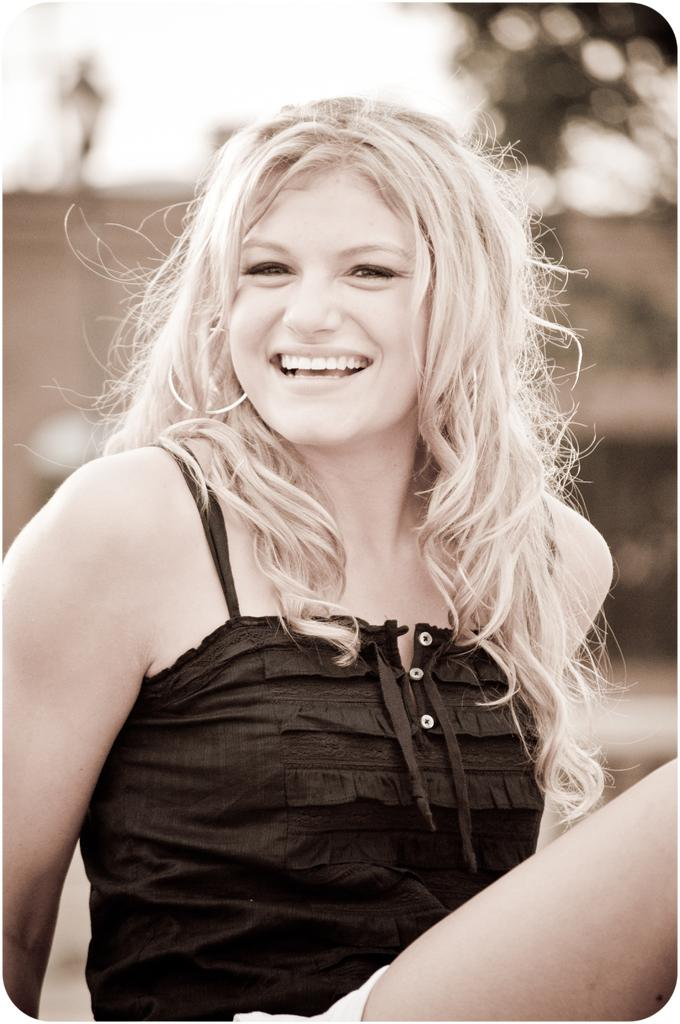Who is present in the image? There is a woman in the image. What is the woman's facial expression? The woman has a smiling face. What is the woman's position in the image? The woman is sitting on the ground. What can be seen in the background of the image? There are objects in the background of the image. How is the background of the image depicted? The background of the image is blurred. Can you tell me how many rivers are visible in the background of the image? There are no rivers visible in the background of the image. What type of sea creatures can be seen in the image? There are no sea creatures present in the image. 